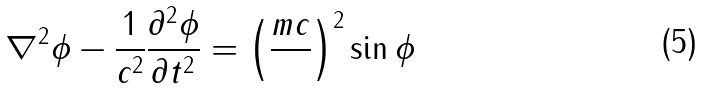Convert formula to latex. <formula><loc_0><loc_0><loc_500><loc_500>\nabla ^ { 2 } \phi - \frac { 1 } { c ^ { 2 } } \frac { \partial ^ { 2 } \phi } { \partial t ^ { 2 } } = \left ( \frac { m c } { } \right ) ^ { 2 } \sin \phi</formula> 